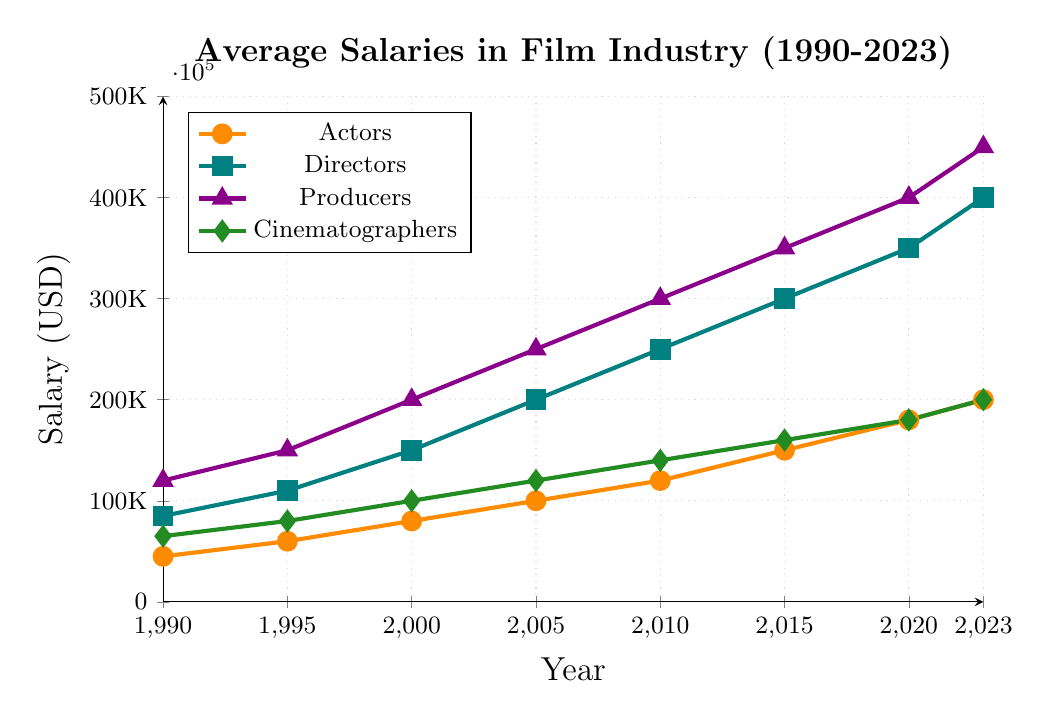What has been the trend in average salaries for actors from 1990 to 2023? The line for actors points upwards steadily from 1990 to 2023, indicating an increase in average salary from $45,000 to $200,000.
Answer: Increasing Which role had the highest average salary in 2023? In 2023, the producer role reached an average salary of $450,000, which is higher than the other roles at this point in time.
Answer: Producer How much more do producers earn on average compared to cinematographers in 2023? In 2023, producers earn $450,000 while cinematographers earn $200,000. The difference is $450,000 - $200,000 = $250,000.
Answer: $250,000 Which role showed the greatest increase in average salary from 1990 to 2023? Producers increased from $120,000 in 1990 to $450,000 in 2023, an increase of $330,000, which is the highest among the roles.
Answer: Producers How does the average salary of directors in 2005 compare to that of actors in the same year? The chart shows that directors had an average salary of $200,000 and actors had $100,000 in 2005, indicating directors earned $100,000 more.
Answer: Directors earned $100,000 more What is the average salary of cinematographers in the years 2010 and 2023? The average salary for cinematographers in 2010 is $140,000 and in 2023 is $200,000. The average of these two values is ($140,000 + $200,000) / 2 = $170,000.
Answer: $170,000 Which role shows the most consistent growth rate in salary over the years? By observing the slope of each line, the role of Actors shows a consistent, steady growth without sharp increases or decreases in the line.
Answer: Actors Comparing 1995 and 2015, how did the salary of directors change? In 1995, directors earned $110,000, and in 2015, they earned $300,000, indicating an increase of $190,000.
Answer: Increased by $190,000 If the current trend continues, what might be the expected average salary for actors in 2025? The trend for actors has shown an approximate increase of $20,000 every 3 years since 2015. Projecting this pattern forward, the expected salary might be around $220,000 in 2025.
Answer: $220,000 